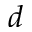<formula> <loc_0><loc_0><loc_500><loc_500>d</formula> 